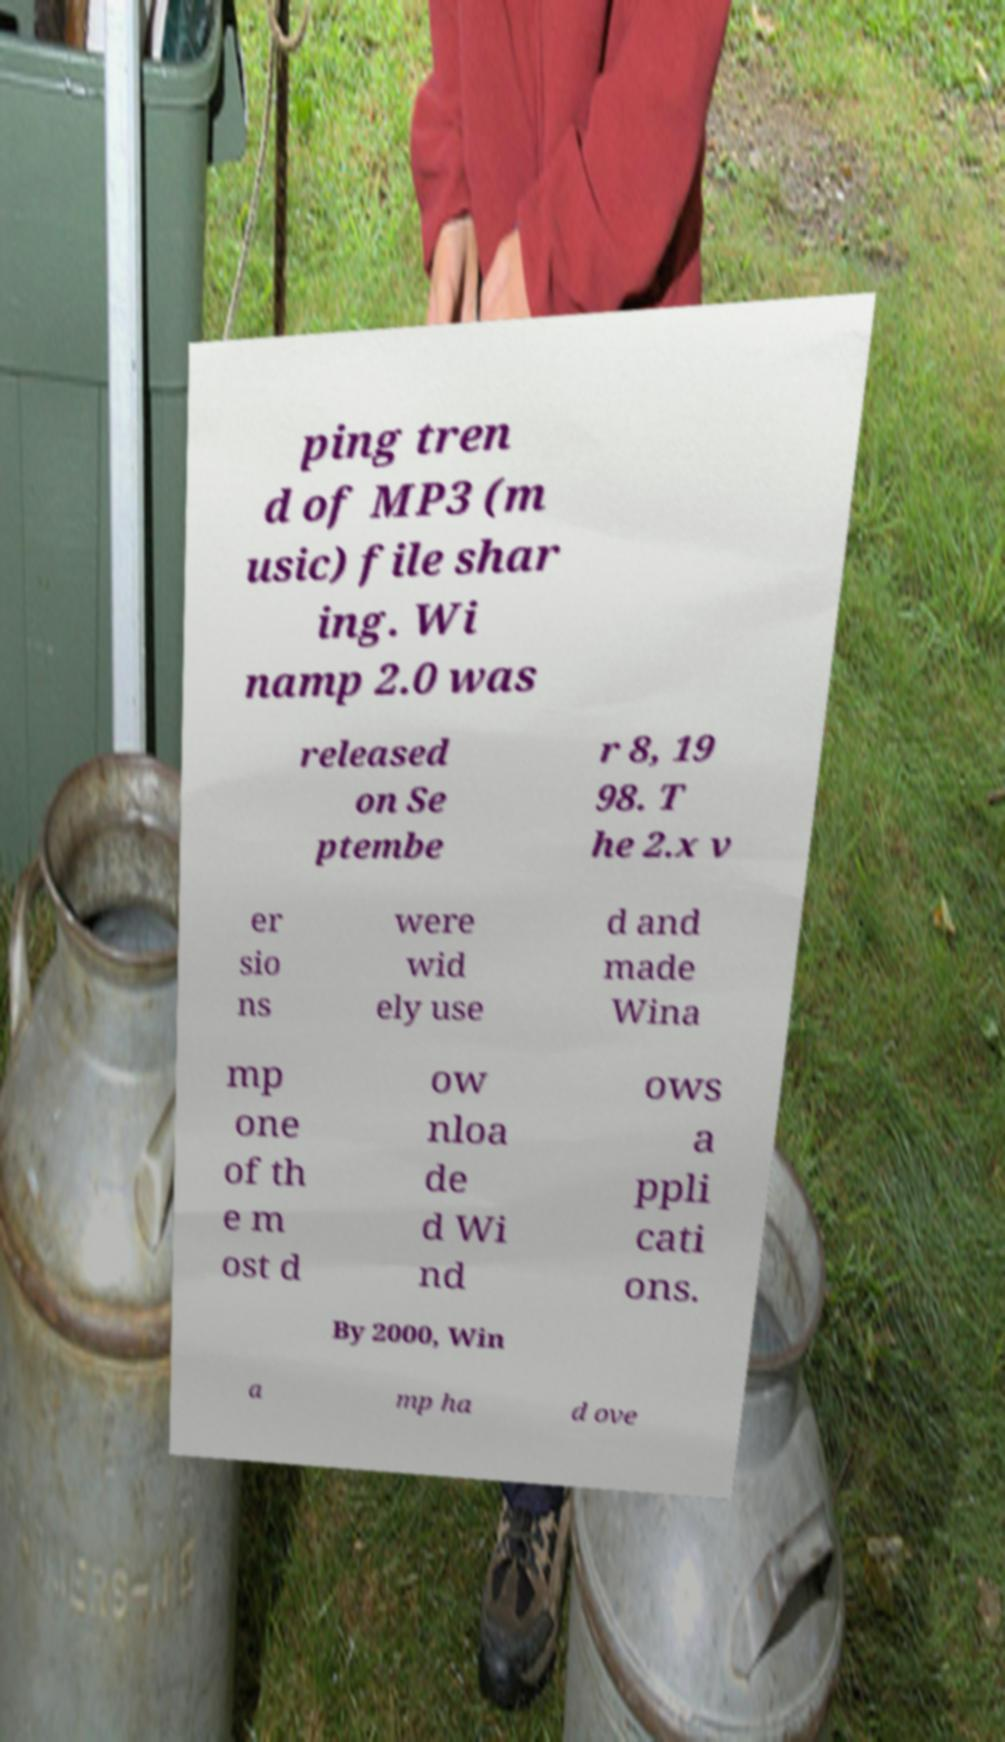For documentation purposes, I need the text within this image transcribed. Could you provide that? ping tren d of MP3 (m usic) file shar ing. Wi namp 2.0 was released on Se ptembe r 8, 19 98. T he 2.x v er sio ns were wid ely use d and made Wina mp one of th e m ost d ow nloa de d Wi nd ows a ppli cati ons. By 2000, Win a mp ha d ove 